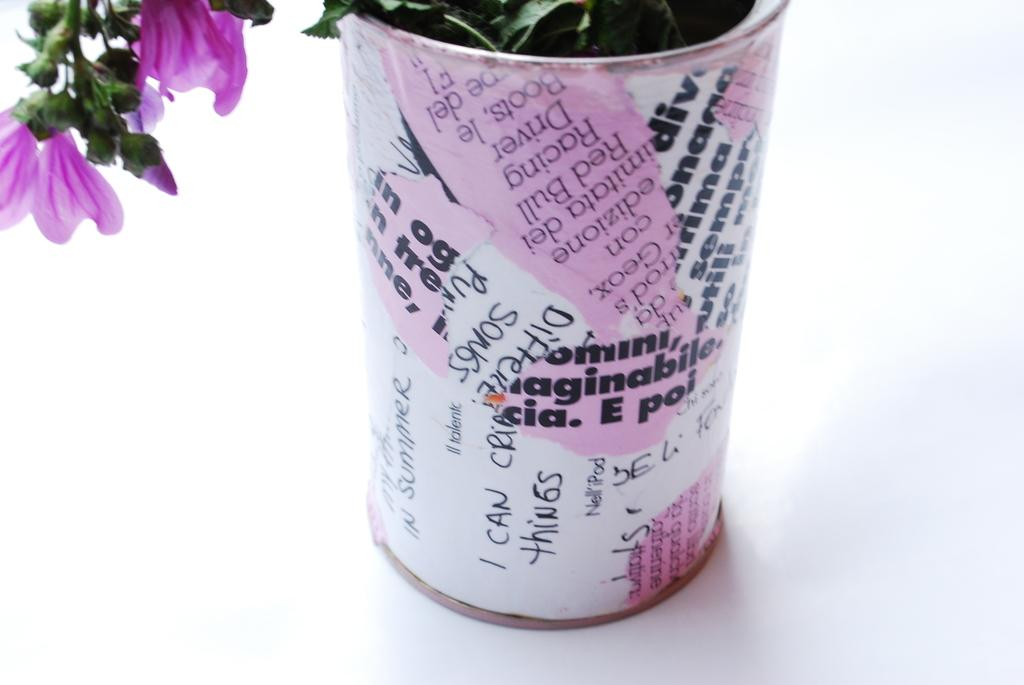What object is present in the image that holds a plant? There is a flower pot in the image that holds a plant. What can be seen on the flower pot? The flower pot has wordings on it and a pink color painting. What type of plant is in the flower pot? The plant in the flower pot has pink color flowers. Can you describe the flowers on the plant? The flowers have petals and buds. What is the income of the girl holding the fowl in the image? There is no girl holding a fowl in the image; it features a flower pot with a plant. 